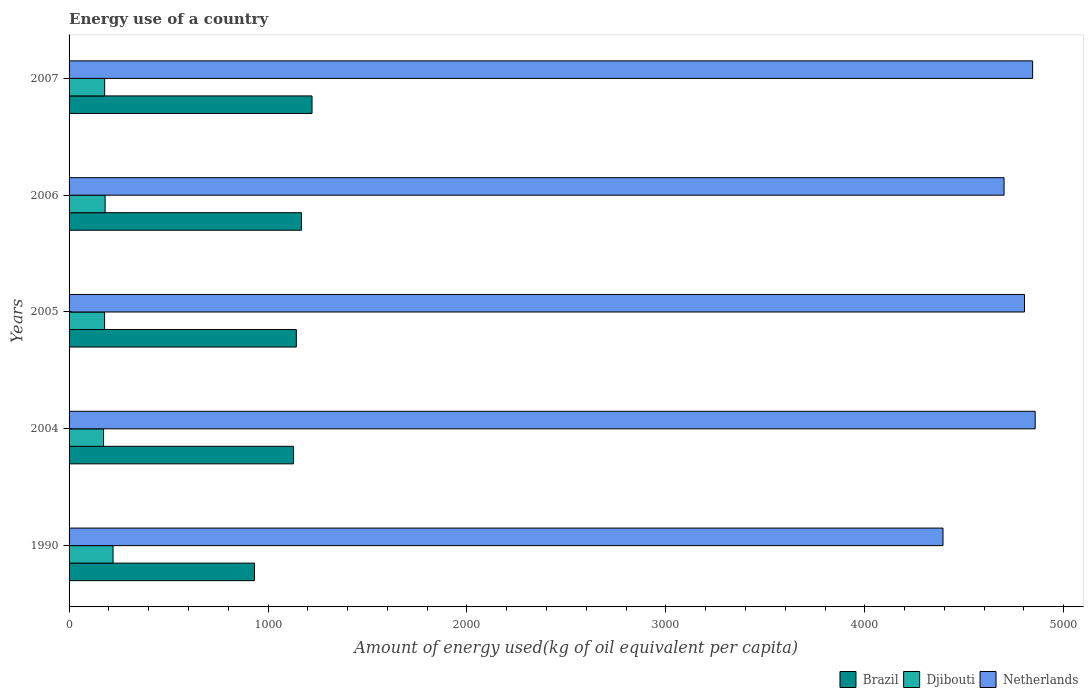How many different coloured bars are there?
Ensure brevity in your answer.  3. Are the number of bars per tick equal to the number of legend labels?
Provide a short and direct response. Yes. How many bars are there on the 4th tick from the top?
Offer a terse response. 3. How many bars are there on the 5th tick from the bottom?
Make the answer very short. 3. What is the label of the 2nd group of bars from the top?
Offer a terse response. 2006. What is the amount of energy used in in Brazil in 2006?
Keep it short and to the point. 1168.43. Across all years, what is the maximum amount of energy used in in Brazil?
Your answer should be very brief. 1221.36. Across all years, what is the minimum amount of energy used in in Djibouti?
Offer a terse response. 173.26. In which year was the amount of energy used in in Brazil minimum?
Offer a terse response. 1990. What is the total amount of energy used in in Brazil in the graph?
Give a very brief answer. 5593.08. What is the difference between the amount of energy used in in Netherlands in 2004 and that in 2005?
Offer a very short reply. 53.68. What is the difference between the amount of energy used in in Brazil in 2004 and the amount of energy used in in Djibouti in 2007?
Make the answer very short. 949.65. What is the average amount of energy used in in Djibouti per year?
Ensure brevity in your answer.  186.61. In the year 2007, what is the difference between the amount of energy used in in Djibouti and amount of energy used in in Brazil?
Offer a very short reply. -1042.46. What is the ratio of the amount of energy used in in Djibouti in 1990 to that in 2007?
Keep it short and to the point. 1.24. Is the amount of energy used in in Djibouti in 1990 less than that in 2004?
Provide a succinct answer. No. Is the difference between the amount of energy used in in Djibouti in 1990 and 2005 greater than the difference between the amount of energy used in in Brazil in 1990 and 2005?
Your answer should be compact. Yes. What is the difference between the highest and the second highest amount of energy used in in Djibouti?
Make the answer very short. 39.8. What is the difference between the highest and the lowest amount of energy used in in Djibouti?
Your answer should be very brief. 47.79. In how many years, is the amount of energy used in in Brazil greater than the average amount of energy used in in Brazil taken over all years?
Your answer should be very brief. 4. What does the 1st bar from the top in 2005 represents?
Your response must be concise. Netherlands. What does the 1st bar from the bottom in 2007 represents?
Provide a short and direct response. Brazil. How many bars are there?
Your answer should be very brief. 15. Are all the bars in the graph horizontal?
Provide a succinct answer. Yes. How many years are there in the graph?
Your answer should be very brief. 5. What is the difference between two consecutive major ticks on the X-axis?
Your answer should be compact. 1000. Does the graph contain any zero values?
Offer a terse response. No. How are the legend labels stacked?
Your answer should be very brief. Horizontal. What is the title of the graph?
Make the answer very short. Energy use of a country. What is the label or title of the X-axis?
Ensure brevity in your answer.  Amount of energy used(kg of oil equivalent per capita). What is the Amount of energy used(kg of oil equivalent per capita) in Brazil in 1990?
Offer a very short reply. 932.26. What is the Amount of energy used(kg of oil equivalent per capita) in Djibouti in 1990?
Give a very brief answer. 221.05. What is the Amount of energy used(kg of oil equivalent per capita) in Netherlands in 1990?
Ensure brevity in your answer.  4393.2. What is the Amount of energy used(kg of oil equivalent per capita) in Brazil in 2004?
Your answer should be very brief. 1128.55. What is the Amount of energy used(kg of oil equivalent per capita) of Djibouti in 2004?
Keep it short and to the point. 173.26. What is the Amount of energy used(kg of oil equivalent per capita) of Netherlands in 2004?
Your response must be concise. 4856.64. What is the Amount of energy used(kg of oil equivalent per capita) of Brazil in 2005?
Offer a very short reply. 1142.47. What is the Amount of energy used(kg of oil equivalent per capita) of Djibouti in 2005?
Your response must be concise. 178.57. What is the Amount of energy used(kg of oil equivalent per capita) in Netherlands in 2005?
Provide a succinct answer. 4802.96. What is the Amount of energy used(kg of oil equivalent per capita) in Brazil in 2006?
Offer a very short reply. 1168.43. What is the Amount of energy used(kg of oil equivalent per capita) of Djibouti in 2006?
Offer a very short reply. 181.26. What is the Amount of energy used(kg of oil equivalent per capita) in Netherlands in 2006?
Ensure brevity in your answer.  4700.18. What is the Amount of energy used(kg of oil equivalent per capita) of Brazil in 2007?
Keep it short and to the point. 1221.36. What is the Amount of energy used(kg of oil equivalent per capita) in Djibouti in 2007?
Your answer should be very brief. 178.9. What is the Amount of energy used(kg of oil equivalent per capita) in Netherlands in 2007?
Ensure brevity in your answer.  4843.8. Across all years, what is the maximum Amount of energy used(kg of oil equivalent per capita) of Brazil?
Offer a terse response. 1221.36. Across all years, what is the maximum Amount of energy used(kg of oil equivalent per capita) of Djibouti?
Keep it short and to the point. 221.05. Across all years, what is the maximum Amount of energy used(kg of oil equivalent per capita) in Netherlands?
Provide a short and direct response. 4856.64. Across all years, what is the minimum Amount of energy used(kg of oil equivalent per capita) of Brazil?
Your response must be concise. 932.26. Across all years, what is the minimum Amount of energy used(kg of oil equivalent per capita) in Djibouti?
Your answer should be compact. 173.26. Across all years, what is the minimum Amount of energy used(kg of oil equivalent per capita) of Netherlands?
Make the answer very short. 4393.2. What is the total Amount of energy used(kg of oil equivalent per capita) in Brazil in the graph?
Keep it short and to the point. 5593.08. What is the total Amount of energy used(kg of oil equivalent per capita) of Djibouti in the graph?
Offer a very short reply. 933.04. What is the total Amount of energy used(kg of oil equivalent per capita) in Netherlands in the graph?
Offer a very short reply. 2.36e+04. What is the difference between the Amount of energy used(kg of oil equivalent per capita) in Brazil in 1990 and that in 2004?
Offer a terse response. -196.29. What is the difference between the Amount of energy used(kg of oil equivalent per capita) in Djibouti in 1990 and that in 2004?
Offer a terse response. 47.79. What is the difference between the Amount of energy used(kg of oil equivalent per capita) in Netherlands in 1990 and that in 2004?
Your answer should be compact. -463.44. What is the difference between the Amount of energy used(kg of oil equivalent per capita) in Brazil in 1990 and that in 2005?
Offer a very short reply. -210.21. What is the difference between the Amount of energy used(kg of oil equivalent per capita) in Djibouti in 1990 and that in 2005?
Your answer should be compact. 42.48. What is the difference between the Amount of energy used(kg of oil equivalent per capita) in Netherlands in 1990 and that in 2005?
Your answer should be very brief. -409.76. What is the difference between the Amount of energy used(kg of oil equivalent per capita) of Brazil in 1990 and that in 2006?
Offer a terse response. -236.17. What is the difference between the Amount of energy used(kg of oil equivalent per capita) of Djibouti in 1990 and that in 2006?
Ensure brevity in your answer.  39.8. What is the difference between the Amount of energy used(kg of oil equivalent per capita) in Netherlands in 1990 and that in 2006?
Your answer should be very brief. -306.98. What is the difference between the Amount of energy used(kg of oil equivalent per capita) of Brazil in 1990 and that in 2007?
Your answer should be compact. -289.1. What is the difference between the Amount of energy used(kg of oil equivalent per capita) of Djibouti in 1990 and that in 2007?
Ensure brevity in your answer.  42.15. What is the difference between the Amount of energy used(kg of oil equivalent per capita) in Netherlands in 1990 and that in 2007?
Give a very brief answer. -450.59. What is the difference between the Amount of energy used(kg of oil equivalent per capita) in Brazil in 2004 and that in 2005?
Your answer should be very brief. -13.92. What is the difference between the Amount of energy used(kg of oil equivalent per capita) of Djibouti in 2004 and that in 2005?
Offer a very short reply. -5.31. What is the difference between the Amount of energy used(kg of oil equivalent per capita) of Netherlands in 2004 and that in 2005?
Provide a succinct answer. 53.68. What is the difference between the Amount of energy used(kg of oil equivalent per capita) of Brazil in 2004 and that in 2006?
Ensure brevity in your answer.  -39.88. What is the difference between the Amount of energy used(kg of oil equivalent per capita) in Djibouti in 2004 and that in 2006?
Offer a terse response. -8. What is the difference between the Amount of energy used(kg of oil equivalent per capita) of Netherlands in 2004 and that in 2006?
Keep it short and to the point. 156.46. What is the difference between the Amount of energy used(kg of oil equivalent per capita) in Brazil in 2004 and that in 2007?
Provide a short and direct response. -92.81. What is the difference between the Amount of energy used(kg of oil equivalent per capita) in Djibouti in 2004 and that in 2007?
Provide a short and direct response. -5.65. What is the difference between the Amount of energy used(kg of oil equivalent per capita) in Netherlands in 2004 and that in 2007?
Your response must be concise. 12.84. What is the difference between the Amount of energy used(kg of oil equivalent per capita) of Brazil in 2005 and that in 2006?
Your answer should be very brief. -25.96. What is the difference between the Amount of energy used(kg of oil equivalent per capita) of Djibouti in 2005 and that in 2006?
Make the answer very short. -2.69. What is the difference between the Amount of energy used(kg of oil equivalent per capita) of Netherlands in 2005 and that in 2006?
Your answer should be compact. 102.78. What is the difference between the Amount of energy used(kg of oil equivalent per capita) of Brazil in 2005 and that in 2007?
Make the answer very short. -78.89. What is the difference between the Amount of energy used(kg of oil equivalent per capita) in Djibouti in 2005 and that in 2007?
Your answer should be compact. -0.33. What is the difference between the Amount of energy used(kg of oil equivalent per capita) of Netherlands in 2005 and that in 2007?
Offer a terse response. -40.84. What is the difference between the Amount of energy used(kg of oil equivalent per capita) in Brazil in 2006 and that in 2007?
Provide a short and direct response. -52.93. What is the difference between the Amount of energy used(kg of oil equivalent per capita) of Djibouti in 2006 and that in 2007?
Offer a terse response. 2.35. What is the difference between the Amount of energy used(kg of oil equivalent per capita) of Netherlands in 2006 and that in 2007?
Give a very brief answer. -143.61. What is the difference between the Amount of energy used(kg of oil equivalent per capita) in Brazil in 1990 and the Amount of energy used(kg of oil equivalent per capita) in Djibouti in 2004?
Keep it short and to the point. 759.01. What is the difference between the Amount of energy used(kg of oil equivalent per capita) of Brazil in 1990 and the Amount of energy used(kg of oil equivalent per capita) of Netherlands in 2004?
Offer a very short reply. -3924.37. What is the difference between the Amount of energy used(kg of oil equivalent per capita) of Djibouti in 1990 and the Amount of energy used(kg of oil equivalent per capita) of Netherlands in 2004?
Provide a short and direct response. -4635.59. What is the difference between the Amount of energy used(kg of oil equivalent per capita) in Brazil in 1990 and the Amount of energy used(kg of oil equivalent per capita) in Djibouti in 2005?
Provide a short and direct response. 753.69. What is the difference between the Amount of energy used(kg of oil equivalent per capita) in Brazil in 1990 and the Amount of energy used(kg of oil equivalent per capita) in Netherlands in 2005?
Provide a short and direct response. -3870.7. What is the difference between the Amount of energy used(kg of oil equivalent per capita) of Djibouti in 1990 and the Amount of energy used(kg of oil equivalent per capita) of Netherlands in 2005?
Make the answer very short. -4581.91. What is the difference between the Amount of energy used(kg of oil equivalent per capita) in Brazil in 1990 and the Amount of energy used(kg of oil equivalent per capita) in Djibouti in 2006?
Your answer should be compact. 751.01. What is the difference between the Amount of energy used(kg of oil equivalent per capita) of Brazil in 1990 and the Amount of energy used(kg of oil equivalent per capita) of Netherlands in 2006?
Ensure brevity in your answer.  -3767.92. What is the difference between the Amount of energy used(kg of oil equivalent per capita) of Djibouti in 1990 and the Amount of energy used(kg of oil equivalent per capita) of Netherlands in 2006?
Give a very brief answer. -4479.13. What is the difference between the Amount of energy used(kg of oil equivalent per capita) of Brazil in 1990 and the Amount of energy used(kg of oil equivalent per capita) of Djibouti in 2007?
Your response must be concise. 753.36. What is the difference between the Amount of energy used(kg of oil equivalent per capita) of Brazil in 1990 and the Amount of energy used(kg of oil equivalent per capita) of Netherlands in 2007?
Your answer should be very brief. -3911.53. What is the difference between the Amount of energy used(kg of oil equivalent per capita) in Djibouti in 1990 and the Amount of energy used(kg of oil equivalent per capita) in Netherlands in 2007?
Your response must be concise. -4622.75. What is the difference between the Amount of energy used(kg of oil equivalent per capita) in Brazil in 2004 and the Amount of energy used(kg of oil equivalent per capita) in Djibouti in 2005?
Give a very brief answer. 949.98. What is the difference between the Amount of energy used(kg of oil equivalent per capita) in Brazil in 2004 and the Amount of energy used(kg of oil equivalent per capita) in Netherlands in 2005?
Provide a short and direct response. -3674.41. What is the difference between the Amount of energy used(kg of oil equivalent per capita) of Djibouti in 2004 and the Amount of energy used(kg of oil equivalent per capita) of Netherlands in 2005?
Offer a terse response. -4629.7. What is the difference between the Amount of energy used(kg of oil equivalent per capita) in Brazil in 2004 and the Amount of energy used(kg of oil equivalent per capita) in Djibouti in 2006?
Your answer should be compact. 947.3. What is the difference between the Amount of energy used(kg of oil equivalent per capita) of Brazil in 2004 and the Amount of energy used(kg of oil equivalent per capita) of Netherlands in 2006?
Ensure brevity in your answer.  -3571.63. What is the difference between the Amount of energy used(kg of oil equivalent per capita) in Djibouti in 2004 and the Amount of energy used(kg of oil equivalent per capita) in Netherlands in 2006?
Keep it short and to the point. -4526.93. What is the difference between the Amount of energy used(kg of oil equivalent per capita) of Brazil in 2004 and the Amount of energy used(kg of oil equivalent per capita) of Djibouti in 2007?
Your answer should be compact. 949.65. What is the difference between the Amount of energy used(kg of oil equivalent per capita) of Brazil in 2004 and the Amount of energy used(kg of oil equivalent per capita) of Netherlands in 2007?
Give a very brief answer. -3715.24. What is the difference between the Amount of energy used(kg of oil equivalent per capita) in Djibouti in 2004 and the Amount of energy used(kg of oil equivalent per capita) in Netherlands in 2007?
Make the answer very short. -4670.54. What is the difference between the Amount of energy used(kg of oil equivalent per capita) in Brazil in 2005 and the Amount of energy used(kg of oil equivalent per capita) in Djibouti in 2006?
Ensure brevity in your answer.  961.22. What is the difference between the Amount of energy used(kg of oil equivalent per capita) of Brazil in 2005 and the Amount of energy used(kg of oil equivalent per capita) of Netherlands in 2006?
Give a very brief answer. -3557.71. What is the difference between the Amount of energy used(kg of oil equivalent per capita) of Djibouti in 2005 and the Amount of energy used(kg of oil equivalent per capita) of Netherlands in 2006?
Ensure brevity in your answer.  -4521.61. What is the difference between the Amount of energy used(kg of oil equivalent per capita) of Brazil in 2005 and the Amount of energy used(kg of oil equivalent per capita) of Djibouti in 2007?
Keep it short and to the point. 963.57. What is the difference between the Amount of energy used(kg of oil equivalent per capita) in Brazil in 2005 and the Amount of energy used(kg of oil equivalent per capita) in Netherlands in 2007?
Your response must be concise. -3701.32. What is the difference between the Amount of energy used(kg of oil equivalent per capita) in Djibouti in 2005 and the Amount of energy used(kg of oil equivalent per capita) in Netherlands in 2007?
Give a very brief answer. -4665.23. What is the difference between the Amount of energy used(kg of oil equivalent per capita) of Brazil in 2006 and the Amount of energy used(kg of oil equivalent per capita) of Djibouti in 2007?
Ensure brevity in your answer.  989.53. What is the difference between the Amount of energy used(kg of oil equivalent per capita) of Brazil in 2006 and the Amount of energy used(kg of oil equivalent per capita) of Netherlands in 2007?
Keep it short and to the point. -3675.37. What is the difference between the Amount of energy used(kg of oil equivalent per capita) of Djibouti in 2006 and the Amount of energy used(kg of oil equivalent per capita) of Netherlands in 2007?
Keep it short and to the point. -4662.54. What is the average Amount of energy used(kg of oil equivalent per capita) of Brazil per year?
Your response must be concise. 1118.62. What is the average Amount of energy used(kg of oil equivalent per capita) in Djibouti per year?
Give a very brief answer. 186.61. What is the average Amount of energy used(kg of oil equivalent per capita) of Netherlands per year?
Offer a terse response. 4719.36. In the year 1990, what is the difference between the Amount of energy used(kg of oil equivalent per capita) in Brazil and Amount of energy used(kg of oil equivalent per capita) in Djibouti?
Ensure brevity in your answer.  711.21. In the year 1990, what is the difference between the Amount of energy used(kg of oil equivalent per capita) in Brazil and Amount of energy used(kg of oil equivalent per capita) in Netherlands?
Make the answer very short. -3460.94. In the year 1990, what is the difference between the Amount of energy used(kg of oil equivalent per capita) in Djibouti and Amount of energy used(kg of oil equivalent per capita) in Netherlands?
Offer a very short reply. -4172.15. In the year 2004, what is the difference between the Amount of energy used(kg of oil equivalent per capita) of Brazil and Amount of energy used(kg of oil equivalent per capita) of Djibouti?
Offer a terse response. 955.3. In the year 2004, what is the difference between the Amount of energy used(kg of oil equivalent per capita) in Brazil and Amount of energy used(kg of oil equivalent per capita) in Netherlands?
Offer a terse response. -3728.09. In the year 2004, what is the difference between the Amount of energy used(kg of oil equivalent per capita) in Djibouti and Amount of energy used(kg of oil equivalent per capita) in Netherlands?
Your answer should be compact. -4683.38. In the year 2005, what is the difference between the Amount of energy used(kg of oil equivalent per capita) of Brazil and Amount of energy used(kg of oil equivalent per capita) of Djibouti?
Give a very brief answer. 963.9. In the year 2005, what is the difference between the Amount of energy used(kg of oil equivalent per capita) in Brazil and Amount of energy used(kg of oil equivalent per capita) in Netherlands?
Provide a short and direct response. -3660.49. In the year 2005, what is the difference between the Amount of energy used(kg of oil equivalent per capita) of Djibouti and Amount of energy used(kg of oil equivalent per capita) of Netherlands?
Provide a succinct answer. -4624.39. In the year 2006, what is the difference between the Amount of energy used(kg of oil equivalent per capita) in Brazil and Amount of energy used(kg of oil equivalent per capita) in Djibouti?
Your response must be concise. 987.17. In the year 2006, what is the difference between the Amount of energy used(kg of oil equivalent per capita) in Brazil and Amount of energy used(kg of oil equivalent per capita) in Netherlands?
Ensure brevity in your answer.  -3531.75. In the year 2006, what is the difference between the Amount of energy used(kg of oil equivalent per capita) in Djibouti and Amount of energy used(kg of oil equivalent per capita) in Netherlands?
Provide a short and direct response. -4518.93. In the year 2007, what is the difference between the Amount of energy used(kg of oil equivalent per capita) of Brazil and Amount of energy used(kg of oil equivalent per capita) of Djibouti?
Offer a terse response. 1042.46. In the year 2007, what is the difference between the Amount of energy used(kg of oil equivalent per capita) in Brazil and Amount of energy used(kg of oil equivalent per capita) in Netherlands?
Your response must be concise. -3622.43. In the year 2007, what is the difference between the Amount of energy used(kg of oil equivalent per capita) of Djibouti and Amount of energy used(kg of oil equivalent per capita) of Netherlands?
Give a very brief answer. -4664.89. What is the ratio of the Amount of energy used(kg of oil equivalent per capita) of Brazil in 1990 to that in 2004?
Offer a terse response. 0.83. What is the ratio of the Amount of energy used(kg of oil equivalent per capita) in Djibouti in 1990 to that in 2004?
Provide a short and direct response. 1.28. What is the ratio of the Amount of energy used(kg of oil equivalent per capita) in Netherlands in 1990 to that in 2004?
Your answer should be compact. 0.9. What is the ratio of the Amount of energy used(kg of oil equivalent per capita) of Brazil in 1990 to that in 2005?
Your response must be concise. 0.82. What is the ratio of the Amount of energy used(kg of oil equivalent per capita) in Djibouti in 1990 to that in 2005?
Keep it short and to the point. 1.24. What is the ratio of the Amount of energy used(kg of oil equivalent per capita) of Netherlands in 1990 to that in 2005?
Your answer should be compact. 0.91. What is the ratio of the Amount of energy used(kg of oil equivalent per capita) of Brazil in 1990 to that in 2006?
Make the answer very short. 0.8. What is the ratio of the Amount of energy used(kg of oil equivalent per capita) of Djibouti in 1990 to that in 2006?
Provide a succinct answer. 1.22. What is the ratio of the Amount of energy used(kg of oil equivalent per capita) of Netherlands in 1990 to that in 2006?
Your answer should be compact. 0.93. What is the ratio of the Amount of energy used(kg of oil equivalent per capita) of Brazil in 1990 to that in 2007?
Give a very brief answer. 0.76. What is the ratio of the Amount of energy used(kg of oil equivalent per capita) in Djibouti in 1990 to that in 2007?
Provide a succinct answer. 1.24. What is the ratio of the Amount of energy used(kg of oil equivalent per capita) of Netherlands in 1990 to that in 2007?
Keep it short and to the point. 0.91. What is the ratio of the Amount of energy used(kg of oil equivalent per capita) in Djibouti in 2004 to that in 2005?
Your response must be concise. 0.97. What is the ratio of the Amount of energy used(kg of oil equivalent per capita) in Netherlands in 2004 to that in 2005?
Give a very brief answer. 1.01. What is the ratio of the Amount of energy used(kg of oil equivalent per capita) of Brazil in 2004 to that in 2006?
Give a very brief answer. 0.97. What is the ratio of the Amount of energy used(kg of oil equivalent per capita) in Djibouti in 2004 to that in 2006?
Make the answer very short. 0.96. What is the ratio of the Amount of energy used(kg of oil equivalent per capita) in Brazil in 2004 to that in 2007?
Give a very brief answer. 0.92. What is the ratio of the Amount of energy used(kg of oil equivalent per capita) of Djibouti in 2004 to that in 2007?
Your answer should be very brief. 0.97. What is the ratio of the Amount of energy used(kg of oil equivalent per capita) of Netherlands in 2004 to that in 2007?
Give a very brief answer. 1. What is the ratio of the Amount of energy used(kg of oil equivalent per capita) of Brazil in 2005 to that in 2006?
Provide a succinct answer. 0.98. What is the ratio of the Amount of energy used(kg of oil equivalent per capita) of Djibouti in 2005 to that in 2006?
Provide a succinct answer. 0.99. What is the ratio of the Amount of energy used(kg of oil equivalent per capita) in Netherlands in 2005 to that in 2006?
Keep it short and to the point. 1.02. What is the ratio of the Amount of energy used(kg of oil equivalent per capita) in Brazil in 2005 to that in 2007?
Offer a terse response. 0.94. What is the ratio of the Amount of energy used(kg of oil equivalent per capita) of Netherlands in 2005 to that in 2007?
Give a very brief answer. 0.99. What is the ratio of the Amount of energy used(kg of oil equivalent per capita) in Brazil in 2006 to that in 2007?
Provide a short and direct response. 0.96. What is the ratio of the Amount of energy used(kg of oil equivalent per capita) in Djibouti in 2006 to that in 2007?
Offer a very short reply. 1.01. What is the ratio of the Amount of energy used(kg of oil equivalent per capita) of Netherlands in 2006 to that in 2007?
Keep it short and to the point. 0.97. What is the difference between the highest and the second highest Amount of energy used(kg of oil equivalent per capita) of Brazil?
Give a very brief answer. 52.93. What is the difference between the highest and the second highest Amount of energy used(kg of oil equivalent per capita) of Djibouti?
Your answer should be compact. 39.8. What is the difference between the highest and the second highest Amount of energy used(kg of oil equivalent per capita) of Netherlands?
Offer a very short reply. 12.84. What is the difference between the highest and the lowest Amount of energy used(kg of oil equivalent per capita) in Brazil?
Provide a succinct answer. 289.1. What is the difference between the highest and the lowest Amount of energy used(kg of oil equivalent per capita) of Djibouti?
Make the answer very short. 47.79. What is the difference between the highest and the lowest Amount of energy used(kg of oil equivalent per capita) of Netherlands?
Ensure brevity in your answer.  463.44. 